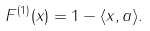Convert formula to latex. <formula><loc_0><loc_0><loc_500><loc_500>F ^ { ( 1 ) } ( x ) = 1 - \langle x , a \rangle .</formula> 